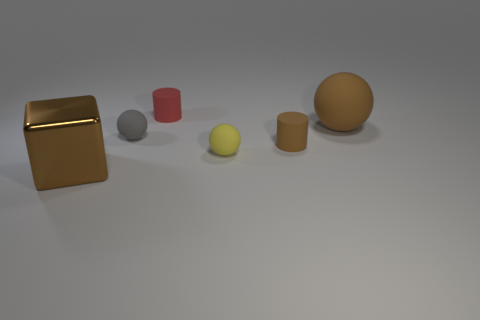Subtract all yellow rubber spheres. How many spheres are left? 2 Add 4 big shiny things. How many objects exist? 10 Subtract all gray spheres. How many spheres are left? 2 Subtract all cubes. How many objects are left? 5 Add 5 small yellow objects. How many small yellow objects are left? 6 Add 2 large gray objects. How many large gray objects exist? 2 Subtract 0 yellow cubes. How many objects are left? 6 Subtract all brown spheres. Subtract all green cylinders. How many spheres are left? 2 Subtract all large brown rubber things. Subtract all big cubes. How many objects are left? 4 